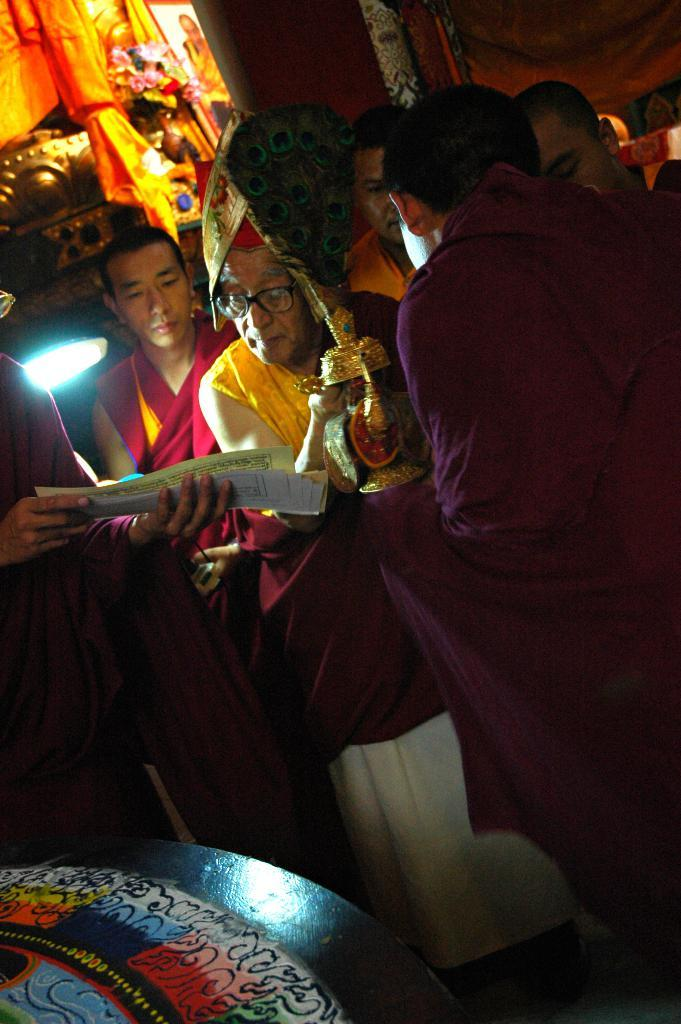How many people can be seen in the image? There are a few people in the image. What is the background of the image? There is a wall visible in the image. What type of material is present in the image? There is some cloth in the image. What is located at the bottom of the image? There is an object at the bottom of the image. What type of drink is being served in the image? There is no drink present in the image. What type of wire can be seen in the image? There is no wire present in the image. 